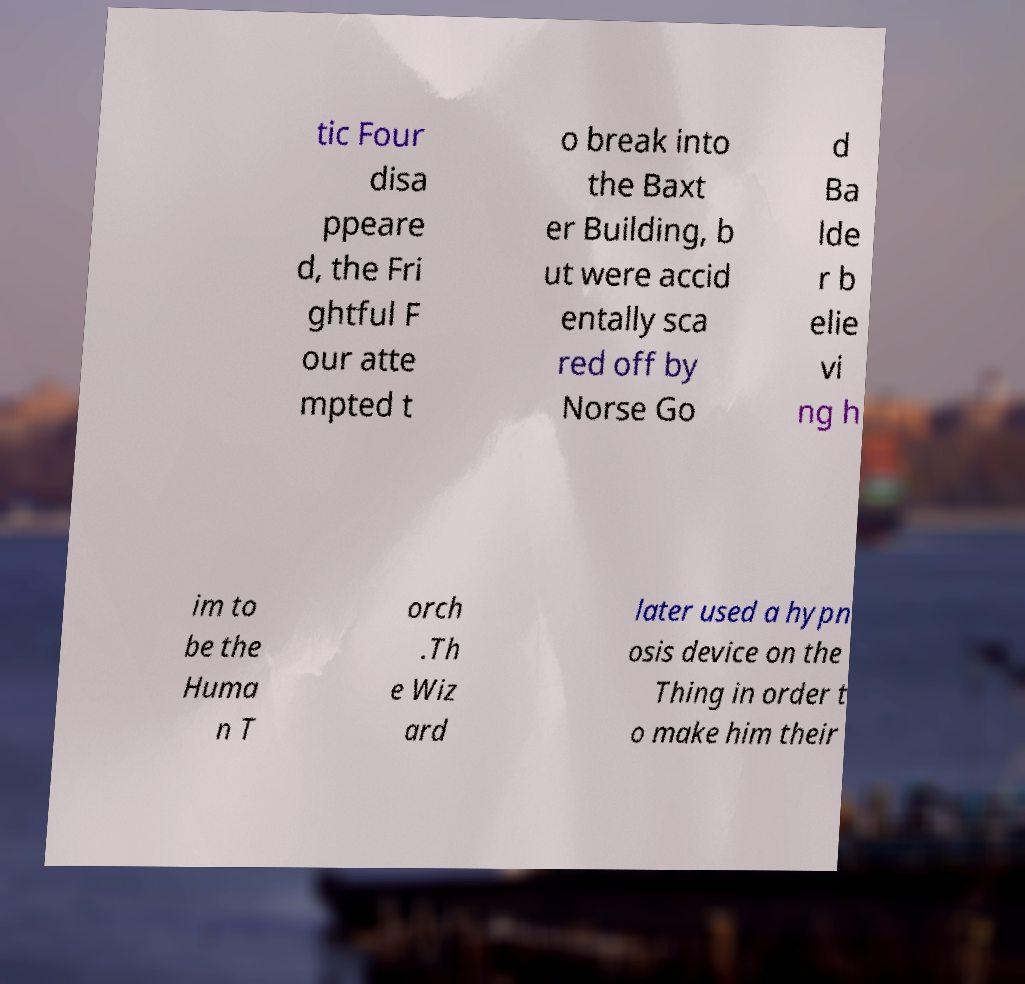I need the written content from this picture converted into text. Can you do that? tic Four disa ppeare d, the Fri ghtful F our atte mpted t o break into the Baxt er Building, b ut were accid entally sca red off by Norse Go d Ba lde r b elie vi ng h im to be the Huma n T orch .Th e Wiz ard later used a hypn osis device on the Thing in order t o make him their 